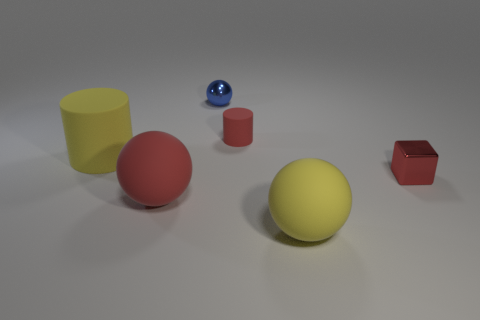Subtract all yellow rubber spheres. How many spheres are left? 2 Subtract all red cylinders. How many cylinders are left? 1 Subtract all blocks. How many objects are left? 5 Subtract 1 yellow cylinders. How many objects are left? 5 Subtract 2 cylinders. How many cylinders are left? 0 Subtract all brown cylinders. Subtract all green cubes. How many cylinders are left? 2 Subtract all gray cylinders. How many green cubes are left? 0 Subtract all big yellow rubber things. Subtract all red things. How many objects are left? 1 Add 2 red cubes. How many red cubes are left? 3 Add 6 red matte spheres. How many red matte spheres exist? 7 